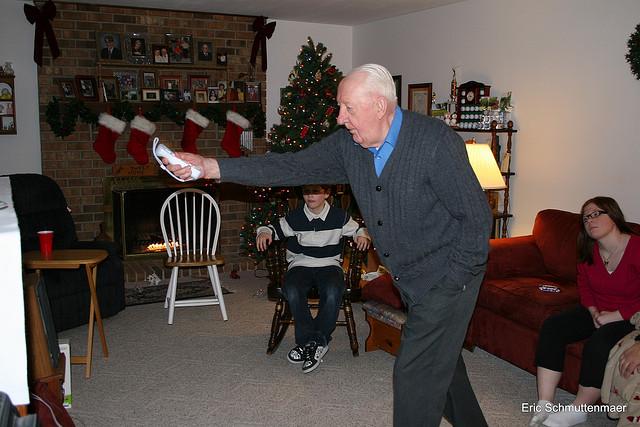Are they touching feet?
Give a very brief answer. No. Is there a bike near the guy?
Answer briefly. No. What shape are the things he's holding?
Keep it brief. Rectangle. Is the man cutting a cake?
Short answer required. No. What is the man wearing?
Write a very short answer. Sweater. How many people are standing?
Answer briefly. 1. Do you see a sign?
Concise answer only. No. How many stockings are on the fireplace?
Write a very short answer. 4. Is this a women?
Be succinct. No. What's he resting on?
Give a very brief answer. Chair. What is the man holding?
Keep it brief. Wii controller. Are they smiling?
Keep it brief. No. Is a teen playing Wii?
Short answer required. No. Is the woman happy?
Quick response, please. No. Is the man watching TV?
Be succinct. Yes. 